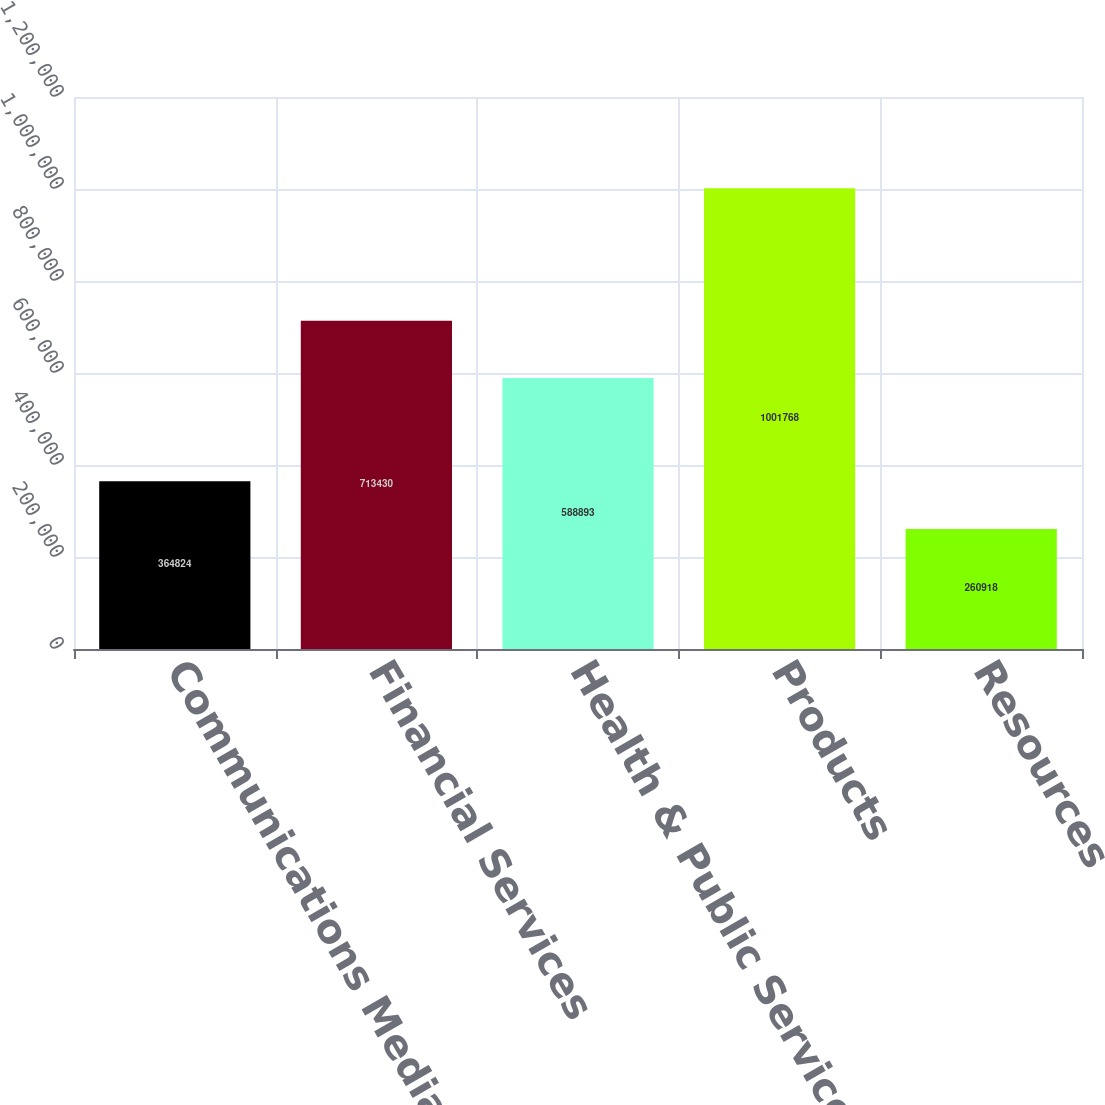Convert chart. <chart><loc_0><loc_0><loc_500><loc_500><bar_chart><fcel>Communications Media &<fcel>Financial Services<fcel>Health & Public Service<fcel>Products<fcel>Resources<nl><fcel>364824<fcel>713430<fcel>588893<fcel>1.00177e+06<fcel>260918<nl></chart> 